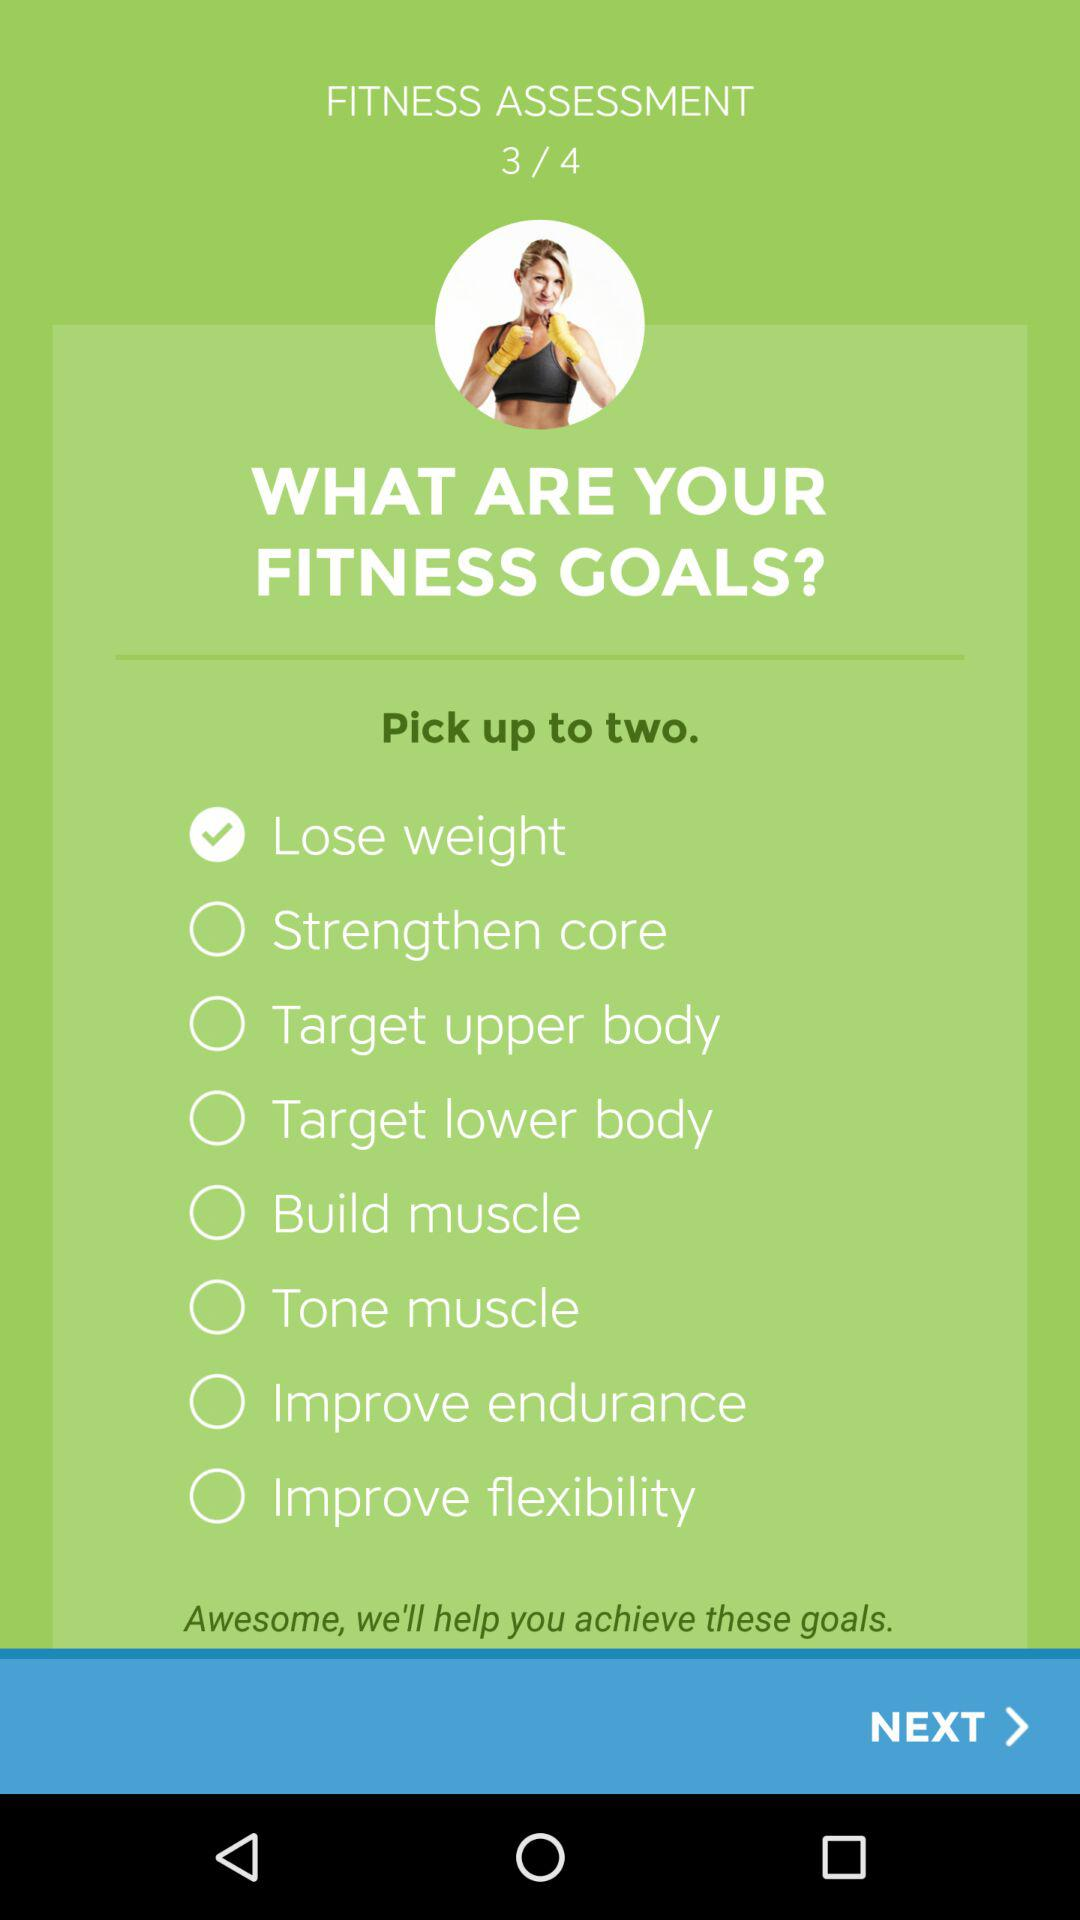What option has been selected for the fitness goal? The option is "Lose weight". 